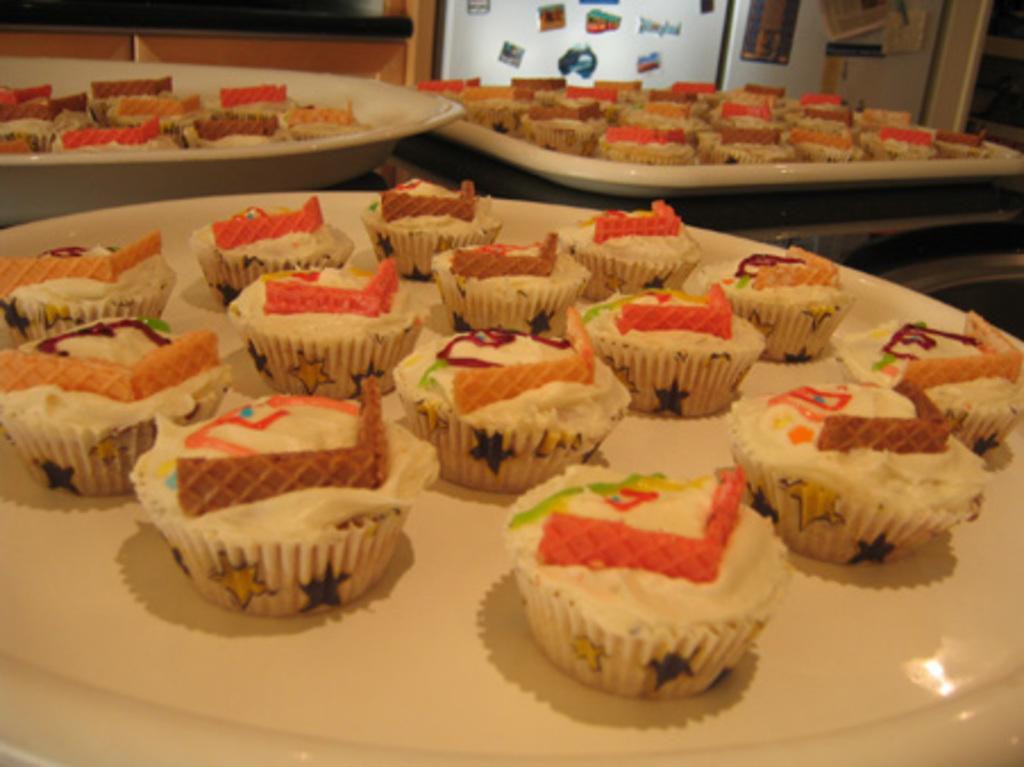Could you give a brief overview of what you see in this image? In the picture we can see a desk on it, we can see a desk with white plates and tray and those are filled with cupcakes and whip cream with wafers which are brown, red in color, in the background we can see a wall with some stickers pasted on it. 